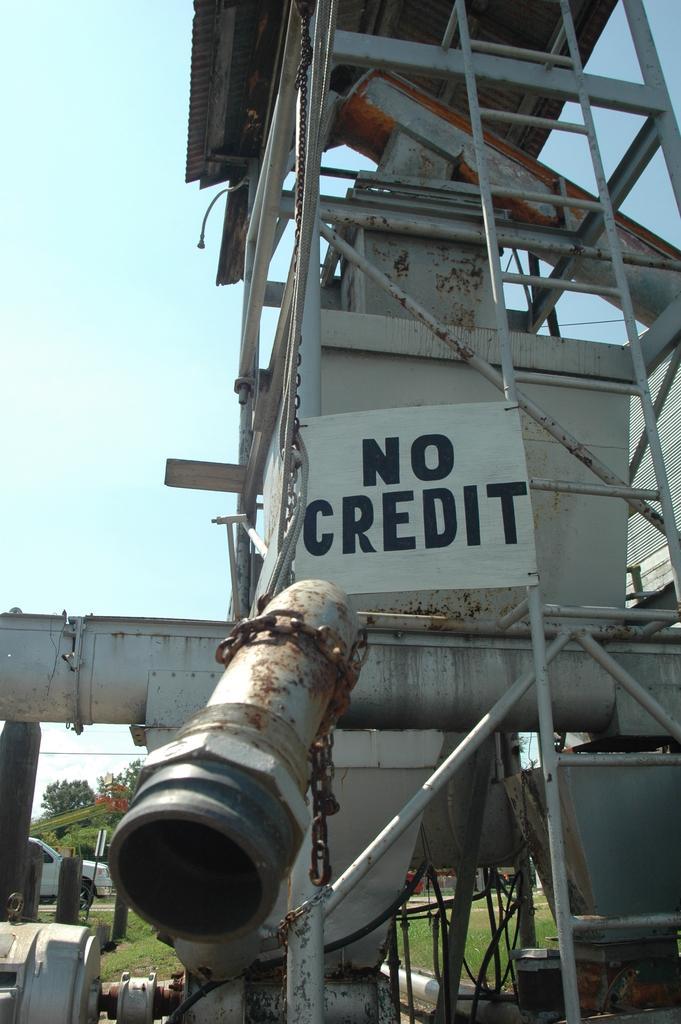Can you describe this image briefly? In this image we can see the machinery and we can see roof at the top and there is a banner with some text on it. In the background, we can see a vehicle and some trees and at the top, we can see the sky. 